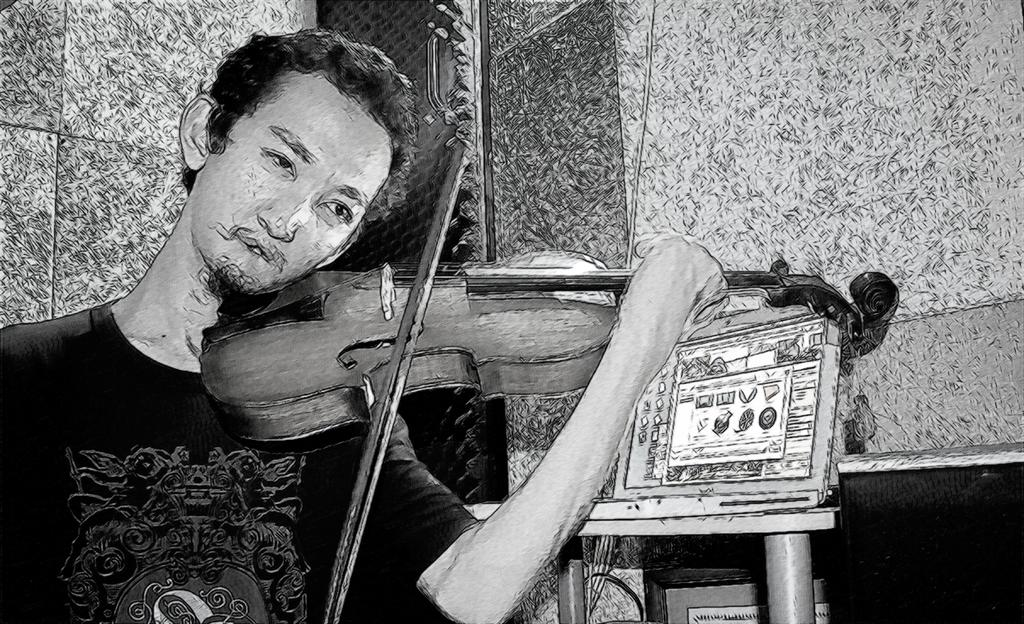What type of artwork is depicted in the image? The image appears to be a painting. Can you describe the subject of the painting? There is a person in the painting. What is the person doing in the painting? The person is playing a musical instrument. What can be seen in the background of the painting? There are objects in the background of the painting, including a wall. What type of ray is visible in the painting? There is no ray present in the painting; it is a painting of a person playing a musical instrument with objects and a wall in the background. Is the painting made with oil paint? The facts provided do not specify the medium used for the painting, so it cannot be determined from the image. 